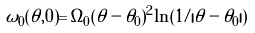<formula> <loc_0><loc_0><loc_500><loc_500>\omega _ { 0 } ( \theta , 0 ) = \Omega _ { 0 } ( \theta - \theta _ { 0 } ) ^ { 2 } \ln ( 1 / | \theta - \theta _ { 0 } | )</formula> 